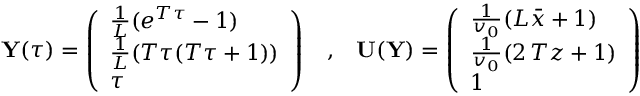Convert formula to latex. <formula><loc_0><loc_0><loc_500><loc_500>{ \mathbf Y } ( \tau ) = \left ( \begin{array} { l } { \frac { 1 } { L } ( e ^ { T \tau } - 1 ) } \\ { \frac { 1 } { L } ( T \tau ( T \tau + 1 ) ) } \\ { \tau } \end{array} \right ) \, , \, { \mathbf U } ( { \mathbf Y } ) = \left ( \begin{array} { l } { \frac { 1 } { v _ { 0 } } ( L \bar { x } + 1 ) } \\ { \frac { 1 } { v _ { 0 } } ( 2 \, T z + 1 ) } \\ { 1 } \end{array} \right )</formula> 